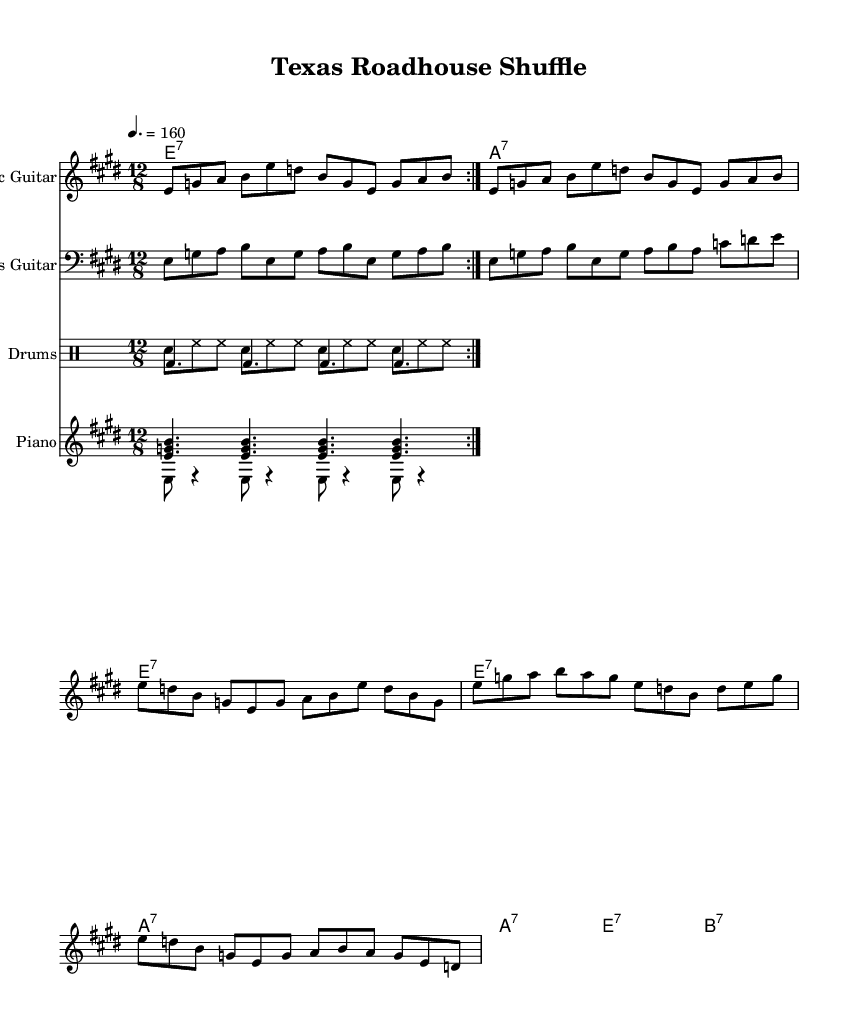What is the key signature of this music? The key signature is E major, which has four sharps (F#, C#, G#, D#). This can be identified by looking at the key signature placed at the beginning of the staff in the sheet music.
Answer: E major What is the time signature of this piece? The time signature is 12/8, which indicates that there are 12 eighth notes in each measure. This can be found in the notation section at the beginning of the score.
Answer: 12/8 What is the tempo marking for this piece? The tempo marking is 160 beats per minute. This is indicated by the tempo marking provided in the score, which specifies how fast the piece should be played.
Answer: 160 How many times is the guitar riff repeated? The guitar riff is repeated two times. This is indicated by the repeat sign shown in the guitar part.
Answer: 2 What chord is played on the first beat of the chorus? The first chord of the chorus is E dominant seventh. This can be determined by looking at the chord symbols above the melody during the chorus section.
Answer: E dominant seventh What is the rhythmic feel characteristic of this music type? The rhythmic feel is a shuffle, created by a triplet feel over the 12/8 time signature, common in electric blues. This can be analyzed by recognizing the division of the notes in the eighth notes that create a swinging feel.
Answer: Shuffle What instrument plays the bass part? The bass part is played by the bass guitar. This is indicated by the instrument name labeled above the staff in the music notation.
Answer: Bass guitar 